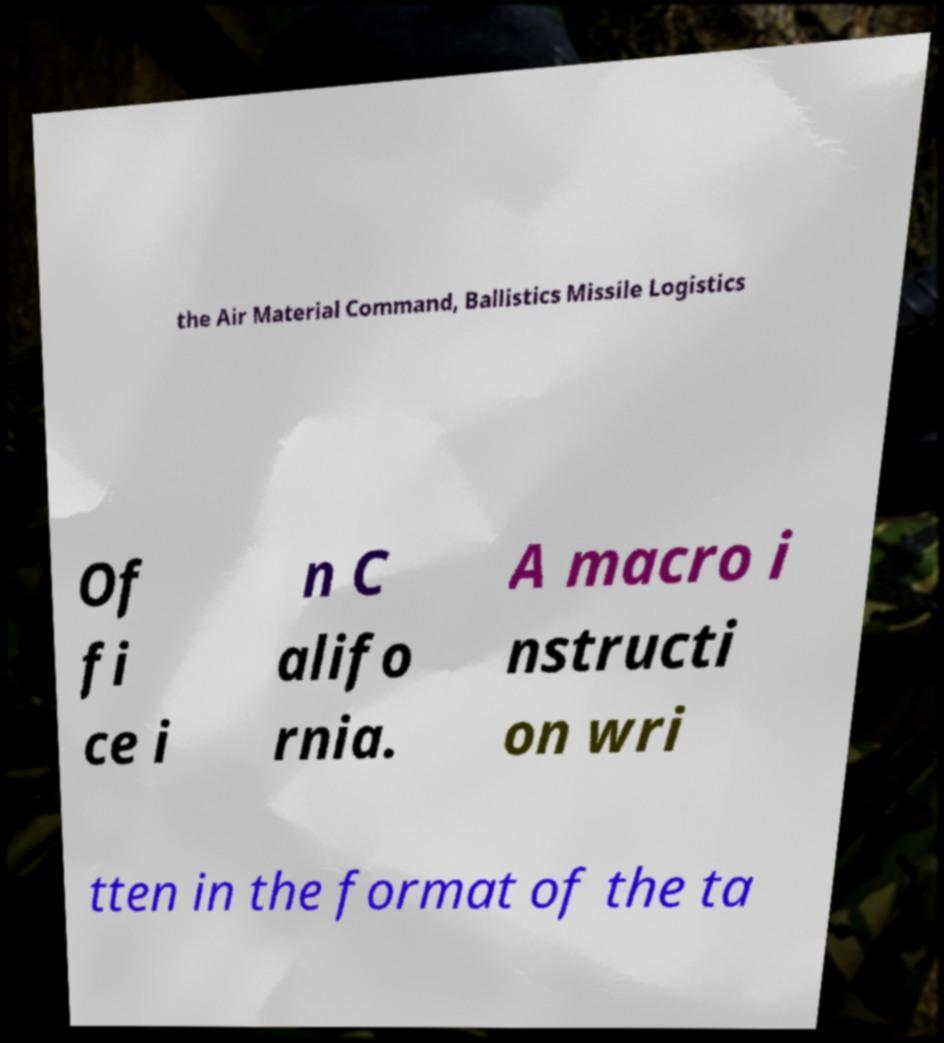Could you assist in decoding the text presented in this image and type it out clearly? the Air Material Command, Ballistics Missile Logistics Of fi ce i n C alifo rnia. A macro i nstructi on wri tten in the format of the ta 